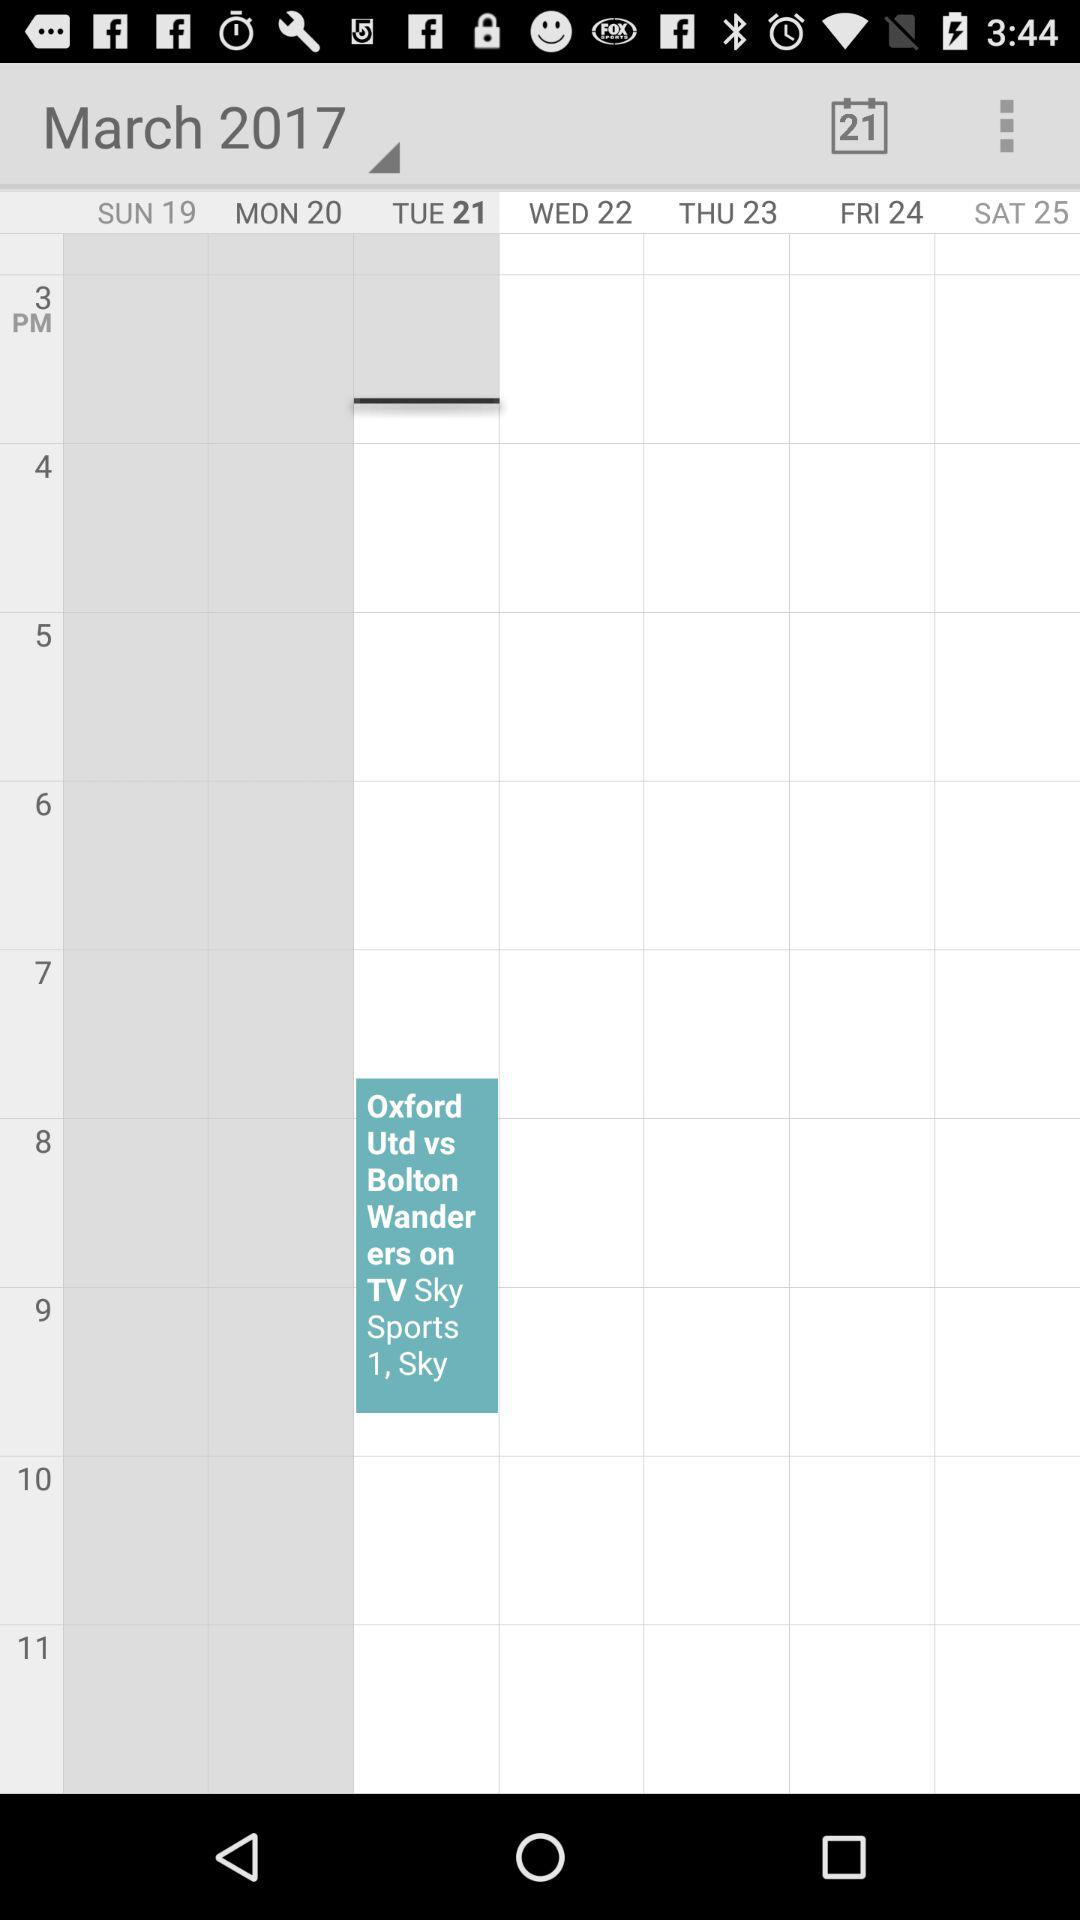What is the selected month? The selected month is March. 